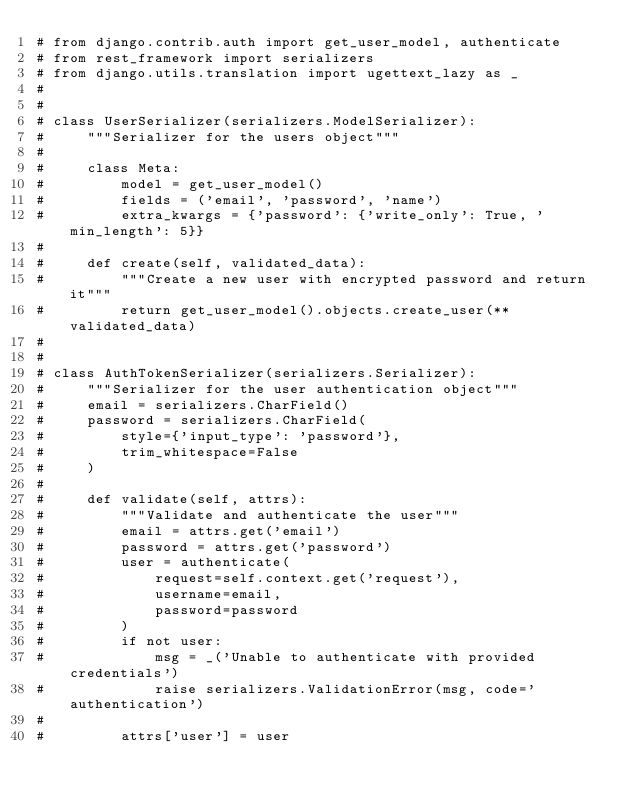<code> <loc_0><loc_0><loc_500><loc_500><_Python_># from django.contrib.auth import get_user_model, authenticate
# from rest_framework import serializers
# from django.utils.translation import ugettext_lazy as _
#
#
# class UserSerializer(serializers.ModelSerializer):
#     """Serializer for the users object"""
#
#     class Meta:
#         model = get_user_model()
#         fields = ('email', 'password', 'name')
#         extra_kwargs = {'password': {'write_only': True, 'min_length': 5}}
#
#     def create(self, validated_data):
#         """Create a new user with encrypted password and return it"""
#         return get_user_model().objects.create_user(**validated_data)
#
#
# class AuthTokenSerializer(serializers.Serializer):
#     """Serializer for the user authentication object"""
#     email = serializers.CharField()
#     password = serializers.CharField(
#         style={'input_type': 'password'},
#         trim_whitespace=False
#     )
#
#     def validate(self, attrs):
#         """Validate and authenticate the user"""
#         email = attrs.get('email')
#         password = attrs.get('password')
#         user = authenticate(
#             request=self.context.get('request'),
#             username=email,
#             password=password
#         )
#         if not user:
#             msg = _('Unable to authenticate with provided credentials')
#             raise serializers.ValidationError(msg, code='authentication')
#
#         attrs['user'] = user</code> 